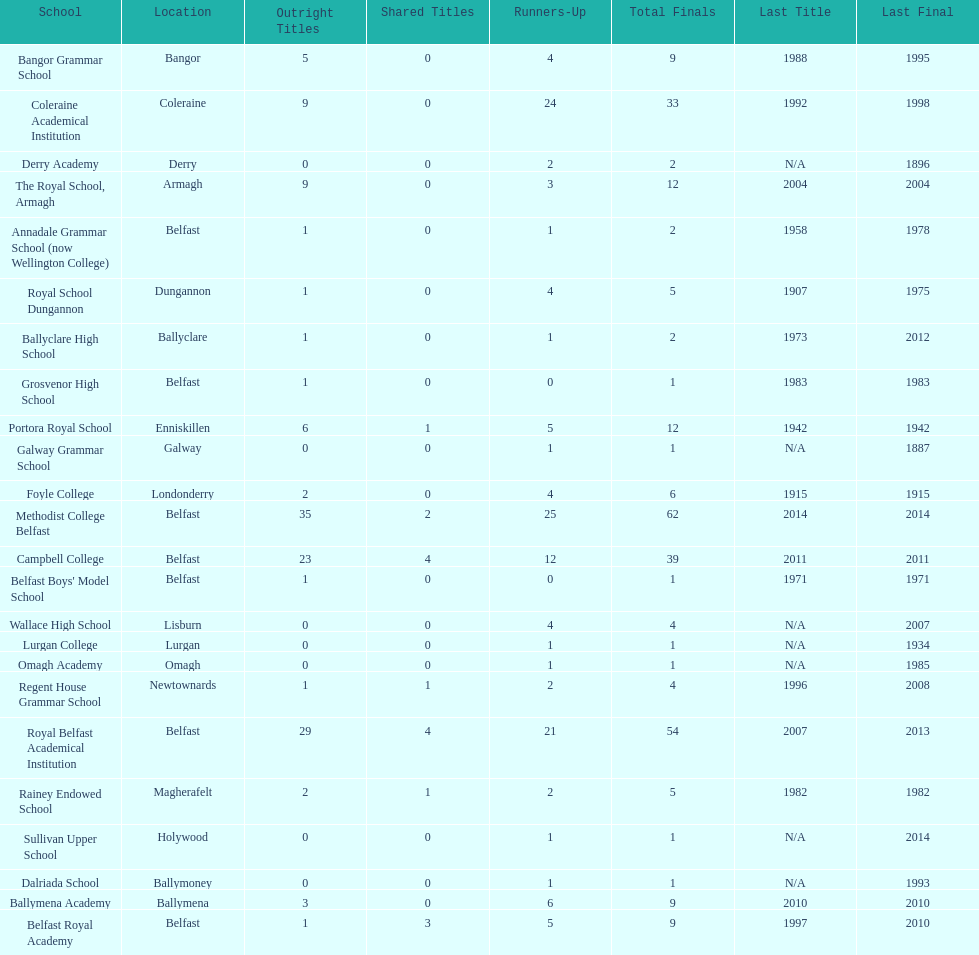What number of total finals does foyle college have? 6. 